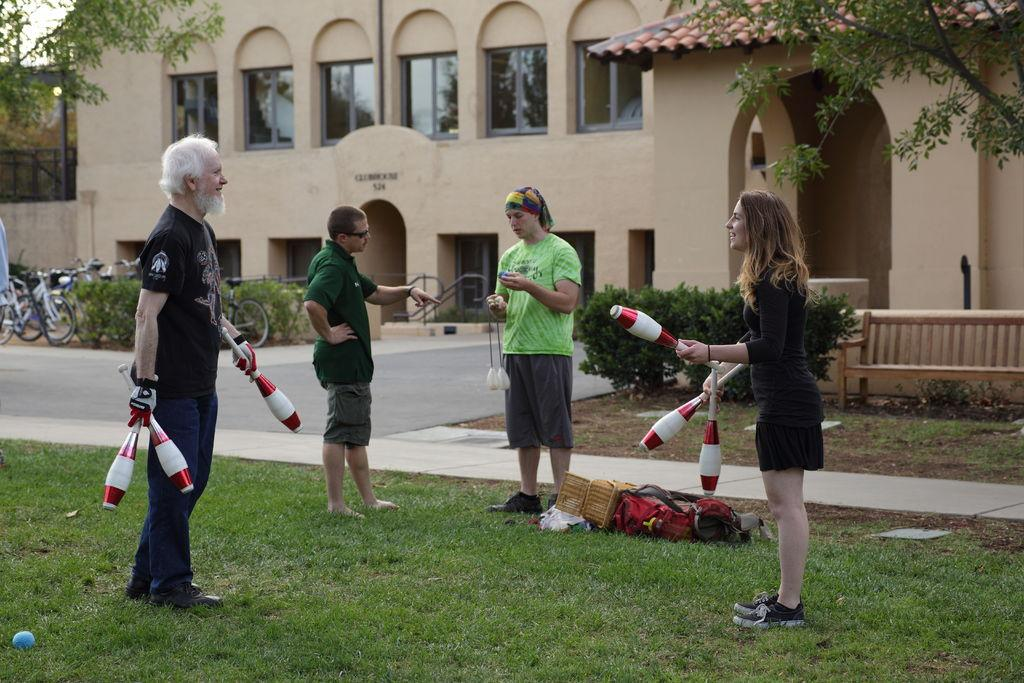How many people are standing on the grass in the image? There are four people standing on the grass in the image. What are two of the people doing? Two of the people are holding juggling pins. What items can be seen in the image besides the people and juggling pins? Bags, plants, buildings, trees, bicycles, and the sky are visible in the image. What type of trousers is the cloud wearing in the image? There is no cloud present in the image, and clouds do not wear trousers. How many smiles can be seen on the people's faces in the image? The provided facts do not mention the expressions on the people's faces, so it is impossible to determine the number of smiles in the image. 